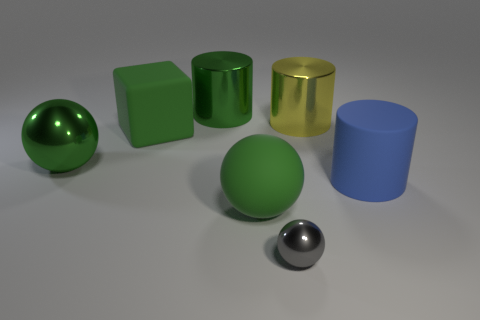Does the small thing have the same color as the large matte sphere?
Ensure brevity in your answer.  No. There is a green rubber thing behind the blue thing; is it the same shape as the green metallic thing that is on the right side of the large metal ball?
Give a very brief answer. No. Are there more tiny brown shiny cylinders than gray things?
Give a very brief answer. No. The matte block is what size?
Offer a terse response. Large. How many other objects are there of the same color as the big cube?
Give a very brief answer. 3. Is the object behind the big yellow shiny object made of the same material as the blue cylinder?
Ensure brevity in your answer.  No. Is the number of gray metallic things left of the small thing less than the number of large green matte objects behind the big blue rubber object?
Give a very brief answer. Yes. What number of other things are there of the same material as the yellow cylinder
Keep it short and to the point. 3. There is a green cylinder that is the same size as the blue cylinder; what is its material?
Your answer should be compact. Metal. Is the number of gray things that are to the right of the big rubber ball less than the number of small gray shiny objects?
Keep it short and to the point. No. 